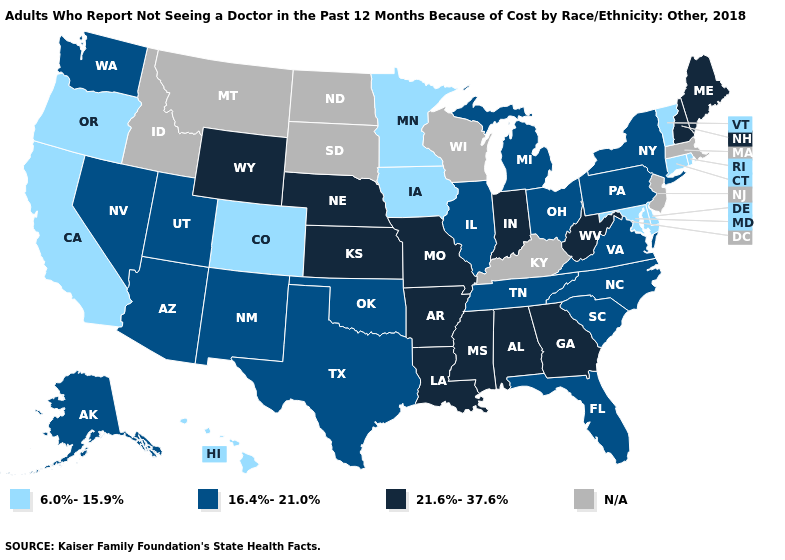Which states hav the highest value in the MidWest?
Short answer required. Indiana, Kansas, Missouri, Nebraska. Does Maine have the highest value in the USA?
Short answer required. Yes. What is the value of Massachusetts?
Answer briefly. N/A. What is the value of California?
Be succinct. 6.0%-15.9%. Which states have the lowest value in the USA?
Be succinct. California, Colorado, Connecticut, Delaware, Hawaii, Iowa, Maryland, Minnesota, Oregon, Rhode Island, Vermont. What is the value of Minnesota?
Short answer required. 6.0%-15.9%. Which states have the lowest value in the USA?
Concise answer only. California, Colorado, Connecticut, Delaware, Hawaii, Iowa, Maryland, Minnesota, Oregon, Rhode Island, Vermont. Does Maryland have the lowest value in the South?
Short answer required. Yes. Name the states that have a value in the range 21.6%-37.6%?
Short answer required. Alabama, Arkansas, Georgia, Indiana, Kansas, Louisiana, Maine, Mississippi, Missouri, Nebraska, New Hampshire, West Virginia, Wyoming. Name the states that have a value in the range N/A?
Answer briefly. Idaho, Kentucky, Massachusetts, Montana, New Jersey, North Dakota, South Dakota, Wisconsin. How many symbols are there in the legend?
Keep it brief. 4. What is the value of Montana?
Answer briefly. N/A. What is the value of New Mexico?
Write a very short answer. 16.4%-21.0%. Does the first symbol in the legend represent the smallest category?
Give a very brief answer. Yes. What is the lowest value in the MidWest?
Short answer required. 6.0%-15.9%. 